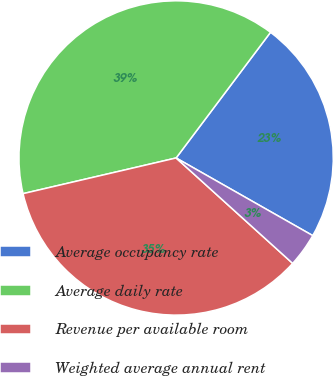<chart> <loc_0><loc_0><loc_500><loc_500><pie_chart><fcel>Average occupancy rate<fcel>Average daily rate<fcel>Revenue per available room<fcel>Weighted average annual rent<nl><fcel>22.97%<fcel>38.9%<fcel>34.65%<fcel>3.48%<nl></chart> 